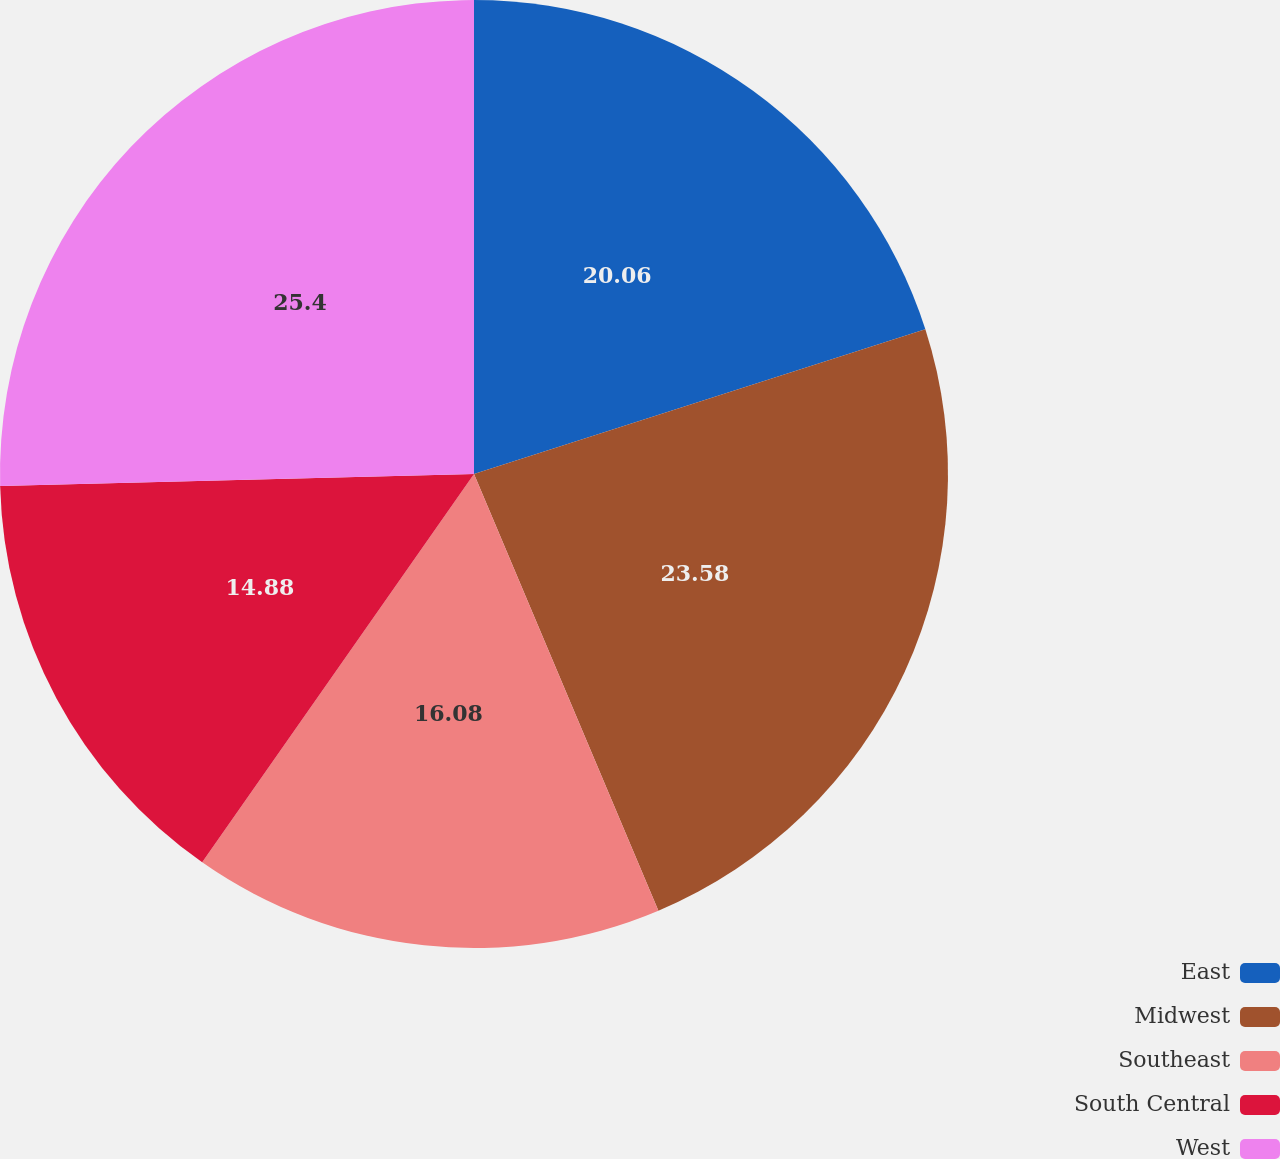Convert chart to OTSL. <chart><loc_0><loc_0><loc_500><loc_500><pie_chart><fcel>East<fcel>Midwest<fcel>Southeast<fcel>South Central<fcel>West<nl><fcel>20.06%<fcel>23.58%<fcel>16.08%<fcel>14.88%<fcel>25.4%<nl></chart> 